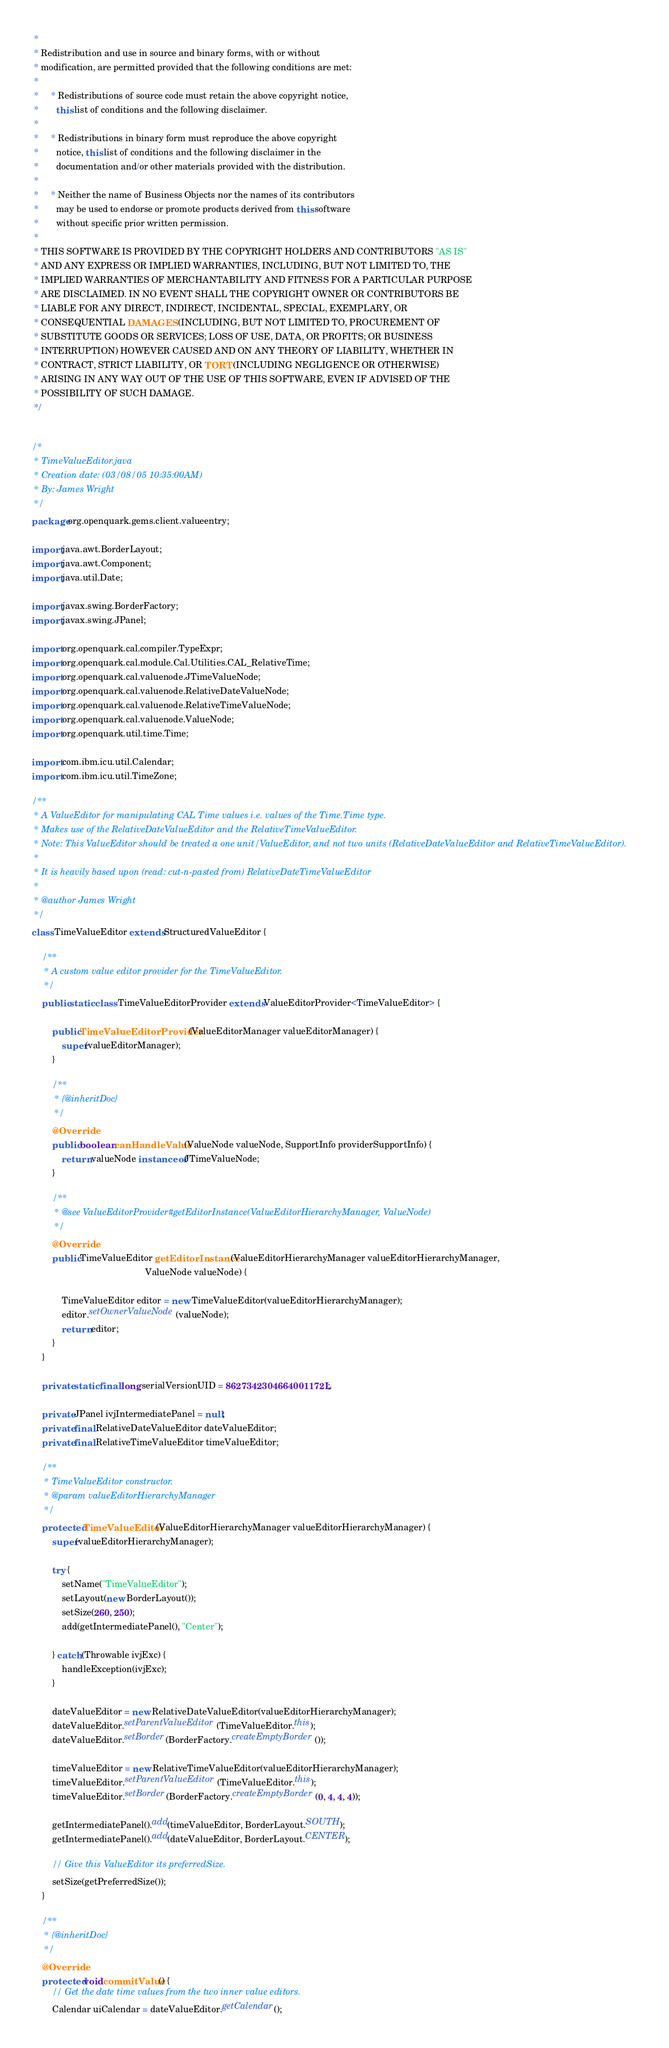Convert code to text. <code><loc_0><loc_0><loc_500><loc_500><_Java_> * 
 * Redistribution and use in source and binary forms, with or without
 * modification, are permitted provided that the following conditions are met:
 * 
 *     * Redistributions of source code must retain the above copyright notice,
 *       this list of conditions and the following disclaimer.
 *  
 *     * Redistributions in binary form must reproduce the above copyright
 *       notice, this list of conditions and the following disclaimer in the
 *       documentation and/or other materials provided with the distribution.
 *  
 *     * Neither the name of Business Objects nor the names of its contributors
 *       may be used to endorse or promote products derived from this software
 *       without specific prior written permission.
 *  
 * THIS SOFTWARE IS PROVIDED BY THE COPYRIGHT HOLDERS AND CONTRIBUTORS "AS IS"
 * AND ANY EXPRESS OR IMPLIED WARRANTIES, INCLUDING, BUT NOT LIMITED TO, THE
 * IMPLIED WARRANTIES OF MERCHANTABILITY AND FITNESS FOR A PARTICULAR PURPOSE
 * ARE DISCLAIMED. IN NO EVENT SHALL THE COPYRIGHT OWNER OR CONTRIBUTORS BE
 * LIABLE FOR ANY DIRECT, INDIRECT, INCIDENTAL, SPECIAL, EXEMPLARY, OR
 * CONSEQUENTIAL DAMAGES (INCLUDING, BUT NOT LIMITED TO, PROCUREMENT OF
 * SUBSTITUTE GOODS OR SERVICES; LOSS OF USE, DATA, OR PROFITS; OR BUSINESS
 * INTERRUPTION) HOWEVER CAUSED AND ON ANY THEORY OF LIABILITY, WHETHER IN
 * CONTRACT, STRICT LIABILITY, OR TORT (INCLUDING NEGLIGENCE OR OTHERWISE)
 * ARISING IN ANY WAY OUT OF THE USE OF THIS SOFTWARE, EVEN IF ADVISED OF THE
 * POSSIBILITY OF SUCH DAMAGE.
 */


/*
 * TimeValueEditor.java
 * Creation date: (03/08/05 10:35:00AM)
 * By: James Wright
 */
package org.openquark.gems.client.valueentry;

import java.awt.BorderLayout;
import java.awt.Component;
import java.util.Date;

import javax.swing.BorderFactory;
import javax.swing.JPanel;

import org.openquark.cal.compiler.TypeExpr;
import org.openquark.cal.module.Cal.Utilities.CAL_RelativeTime;
import org.openquark.cal.valuenode.JTimeValueNode;
import org.openquark.cal.valuenode.RelativeDateValueNode;
import org.openquark.cal.valuenode.RelativeTimeValueNode;
import org.openquark.cal.valuenode.ValueNode;
import org.openquark.util.time.Time;

import com.ibm.icu.util.Calendar;
import com.ibm.icu.util.TimeZone;

/**
 * A ValueEditor for manipulating CAL Time values i.e. values of the Time.Time type.
 * Makes use of the RelativeDateValueEditor and the RelativeTimeValueEditor.
 * Note: This ValueEditor should be treated a one unit/ValueEditor, and not two units (RelativeDateValueEditor and RelativeTimeValueEditor).
 * 
 * It is heavily based upon (read: cut-n-pasted from) RelativeDateTimeValueEditor
 *
 * @author James Wright
 */
class TimeValueEditor extends StructuredValueEditor {
    
    /**
     * A custom value editor provider for the TimeValueEditor.
     */
    public static class TimeValueEditorProvider extends ValueEditorProvider<TimeValueEditor> {
        
        public TimeValueEditorProvider(ValueEditorManager valueEditorManager) {
            super(valueEditorManager);
        }

        /**
         * {@inheritDoc}
         */
        @Override
        public boolean canHandleValue(ValueNode valueNode, SupportInfo providerSupportInfo) {
            return valueNode instanceof JTimeValueNode;
        }

        /**
         * @see ValueEditorProvider#getEditorInstance(ValueEditorHierarchyManager, ValueNode)
         */
        @Override
        public TimeValueEditor getEditorInstance(ValueEditorHierarchyManager valueEditorHierarchyManager,
                                             ValueNode valueNode) {
            
            TimeValueEditor editor = new TimeValueEditor(valueEditorHierarchyManager);
            editor.setOwnerValueNode(valueNode);
            return editor;
        }
    }

    private static final long serialVersionUID = 8627342304664001172L;

    private JPanel ivjIntermediatePanel = null;
    private final RelativeDateValueEditor dateValueEditor;
    private final RelativeTimeValueEditor timeValueEditor;
    
    /**
     * TimeValueEditor constructor.
     * @param valueEditorHierarchyManager
     */
    protected TimeValueEditor(ValueEditorHierarchyManager valueEditorHierarchyManager) {
        super(valueEditorHierarchyManager);

        try {
            setName("TimeValueEditor");
            setLayout(new BorderLayout());
            setSize(260, 250);
            add(getIntermediatePanel(), "Center");

        } catch (Throwable ivjExc) {
            handleException(ivjExc);
        }

        dateValueEditor = new RelativeDateValueEditor(valueEditorHierarchyManager);
        dateValueEditor.setParentValueEditor(TimeValueEditor.this);
        dateValueEditor.setBorder(BorderFactory.createEmptyBorder());
        
        timeValueEditor = new RelativeTimeValueEditor(valueEditorHierarchyManager);
        timeValueEditor.setParentValueEditor(TimeValueEditor.this);
        timeValueEditor.setBorder(BorderFactory.createEmptyBorder(0, 4, 4, 4));

        getIntermediatePanel().add(timeValueEditor, BorderLayout.SOUTH);
        getIntermediatePanel().add(dateValueEditor, BorderLayout.CENTER);

        // Give this ValueEditor its preferredSize.
        setSize(getPreferredSize());
    }
    
    /**
     * {@inheritDoc}
     */
    @Override
    protected void commitValue() {
        // Get the date time values from the two inner value editors.
        Calendar uiCalendar = dateValueEditor.getCalendar();</code> 